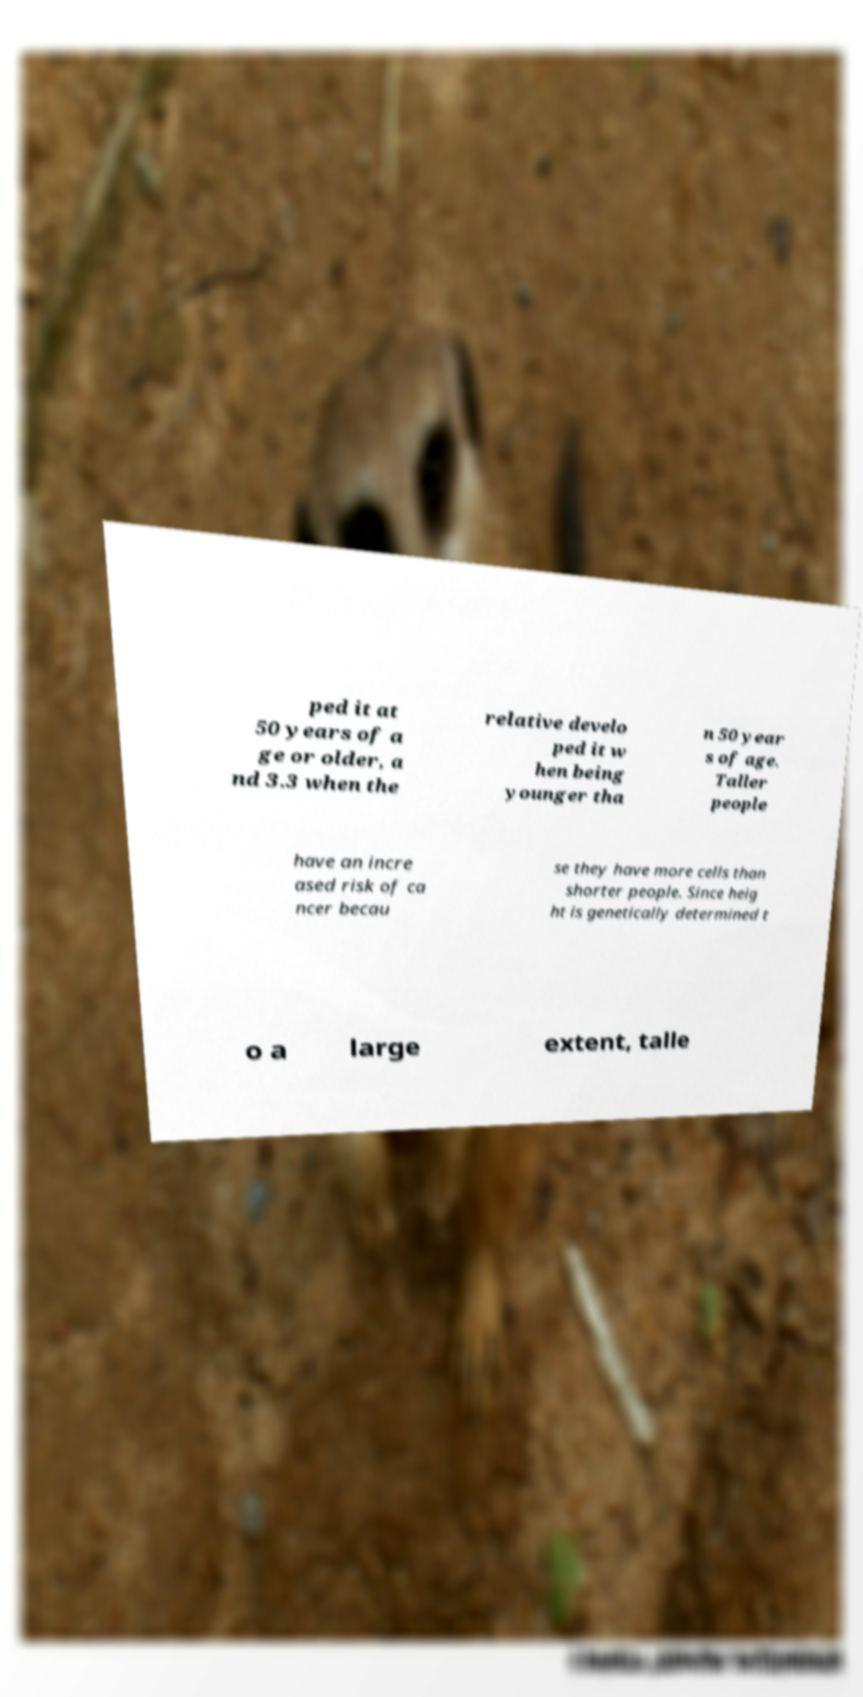Can you accurately transcribe the text from the provided image for me? ped it at 50 years of a ge or older, a nd 3.3 when the relative develo ped it w hen being younger tha n 50 year s of age. Taller people have an incre ased risk of ca ncer becau se they have more cells than shorter people. Since heig ht is genetically determined t o a large extent, talle 